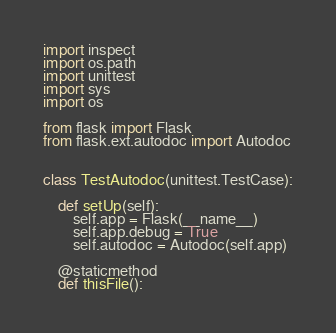<code> <loc_0><loc_0><loc_500><loc_500><_Python_>import inspect
import os.path
import unittest
import sys
import os

from flask import Flask
from flask.ext.autodoc import Autodoc


class TestAutodoc(unittest.TestCase):

    def setUp(self):
        self.app = Flask(__name__)
        self.app.debug = True
        self.autodoc = Autodoc(self.app)

    @staticmethod
    def thisFile():</code> 